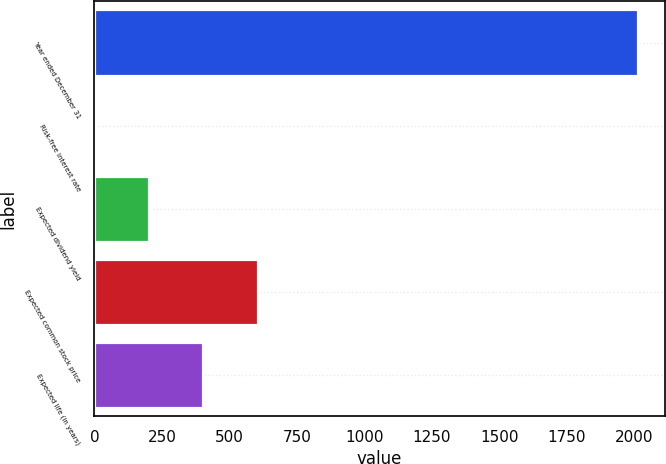<chart> <loc_0><loc_0><loc_500><loc_500><bar_chart><fcel>Year ended December 31<fcel>Risk-free interest rate<fcel>Expected dividend yield<fcel>Expected common stock price<fcel>Expected life (in years)<nl><fcel>2013<fcel>1.18<fcel>202.36<fcel>604.72<fcel>403.54<nl></chart> 